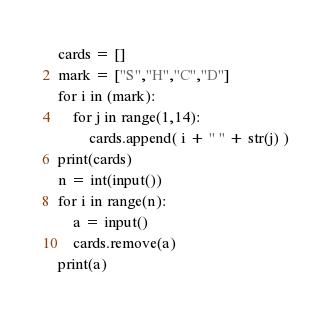<code> <loc_0><loc_0><loc_500><loc_500><_Python_>cards = []
mark = ["S","H","C","D"]
for i in (mark):
    for j in range(1,14):
        cards.append( i + " " + str(j) )
print(cards)
n = int(input())
for i in range(n):
    a = input()
    cards.remove(a)
print(a)</code> 